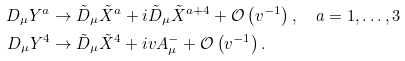Convert formula to latex. <formula><loc_0><loc_0><loc_500><loc_500>D _ { \mu } Y ^ { a } & \rightarrow \tilde { D } _ { \mu } \tilde { X } ^ { a } + i \tilde { D } _ { \mu } \tilde { X } ^ { a + 4 } + \mathcal { O } \left ( v ^ { - 1 } \right ) , \quad a = 1 , \dots , 3 \\ D _ { \mu } Y ^ { 4 } & \rightarrow \tilde { D } _ { \mu } \tilde { X } ^ { 4 } + i v A ^ { - } _ { \mu } + \mathcal { O } \left ( v ^ { - 1 } \right ) .</formula> 